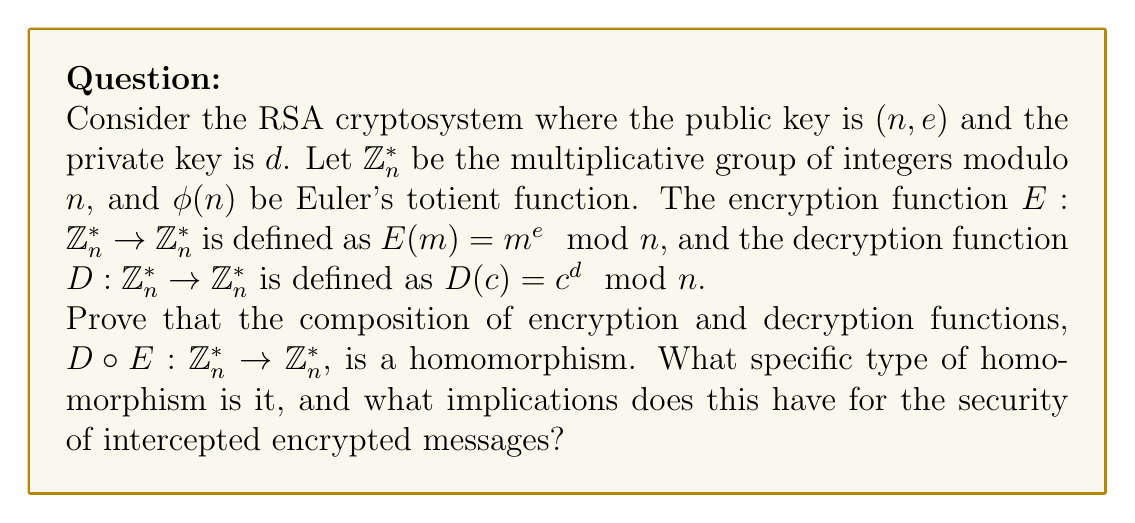Help me with this question. Let's approach this step-by-step:

1) First, recall that in RSA, $ed \equiv 1 \pmod{\phi(n)}$. This means there exists an integer $k$ such that $ed = k\phi(n) + 1$.

2) Now, let's consider the composition $D \circ E$ for any $m \in \mathbb{Z}_n^*$:

   $$(D \circ E)(m) = D(E(m)) = D(m^e \mod n) = (m^e)^d \mod n = m^{ed} \mod n$$

3) Using the relation from step 1, we can write:

   $$m^{ed} \mod n = m^{k\phi(n) + 1} \mod n = (m^{\phi(n)})^k \cdot m \mod n$$

4) By Euler's theorem, we know that for any $m$ coprime to $n$, $m^{\phi(n)} \equiv 1 \pmod{n}$. Therefore:

   $$(m^{\phi(n)})^k \cdot m \mod n \equiv 1^k \cdot m \mod n \equiv m \mod n$$

5) This shows that $(D \circ E)(m) = m$ for all $m \in \mathbb{Z}_n^*$. 

6) To prove that $D \circ E$ is a homomorphism, we need to show that for any $a, b \in \mathbb{Z}_n^*$:

   $$(D \circ E)(ab) = (D \circ E)(a) \cdot (D \circ E)(b)$$

   Indeed, $(D \circ E)(ab) = ab = (D \circ E)(a) \cdot (D \circ E)(b)$

7) This homomorphism is actually an automorphism, as it's both one-to-one and onto. In fact, it's the identity automorphism.

8) For intercepted messages, this means that applying the decryption function to an encrypted message will always recover the original message, regardless of the specific values of $e$ and $d$. However, without knowing $d$, an interceptor cannot perform this operation.
Answer: $D \circ E$ is the identity automorphism on $\mathbb{Z}_n^*$. 